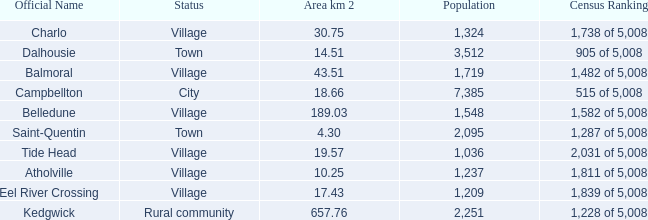When the communities name is Balmoral and the area is over 43.51 kilometers squared, what's the total population amount? 0.0. 